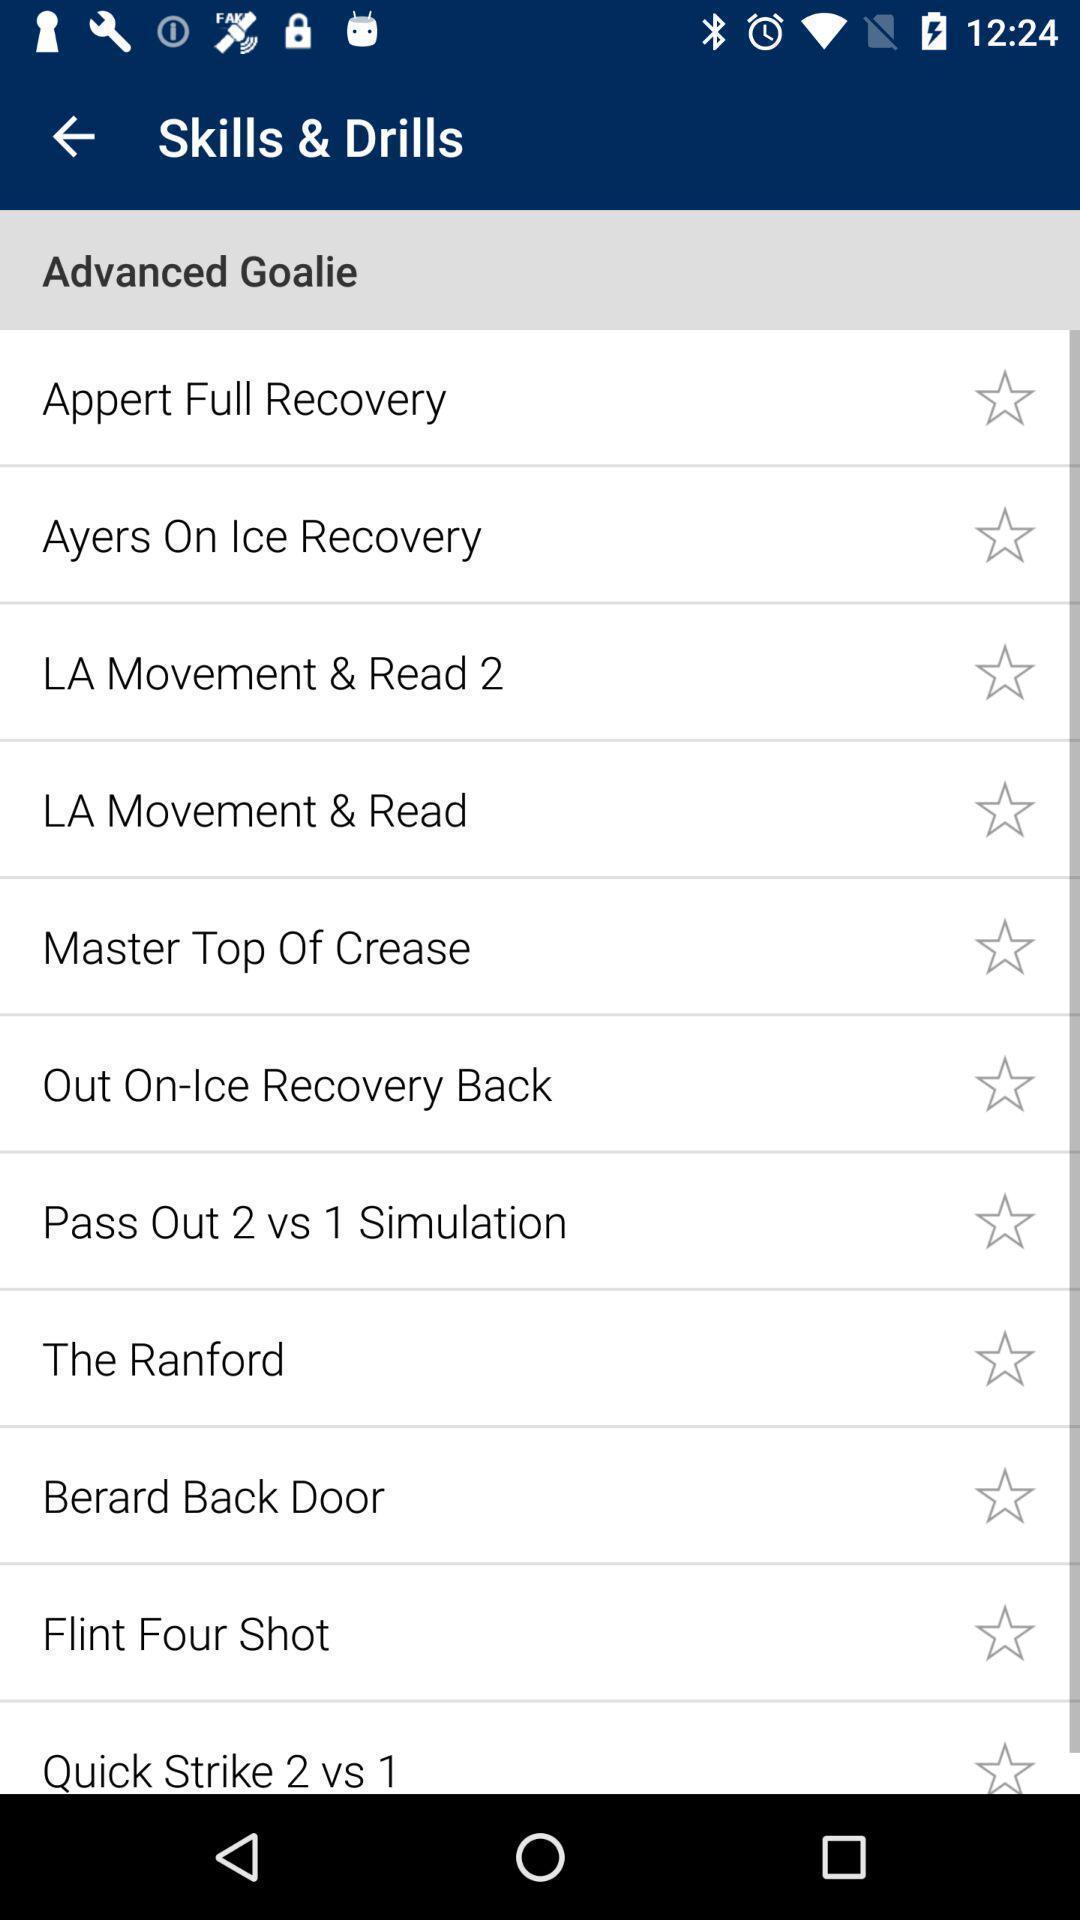What details can you identify in this image? Screen showing list of various skill and drills. 